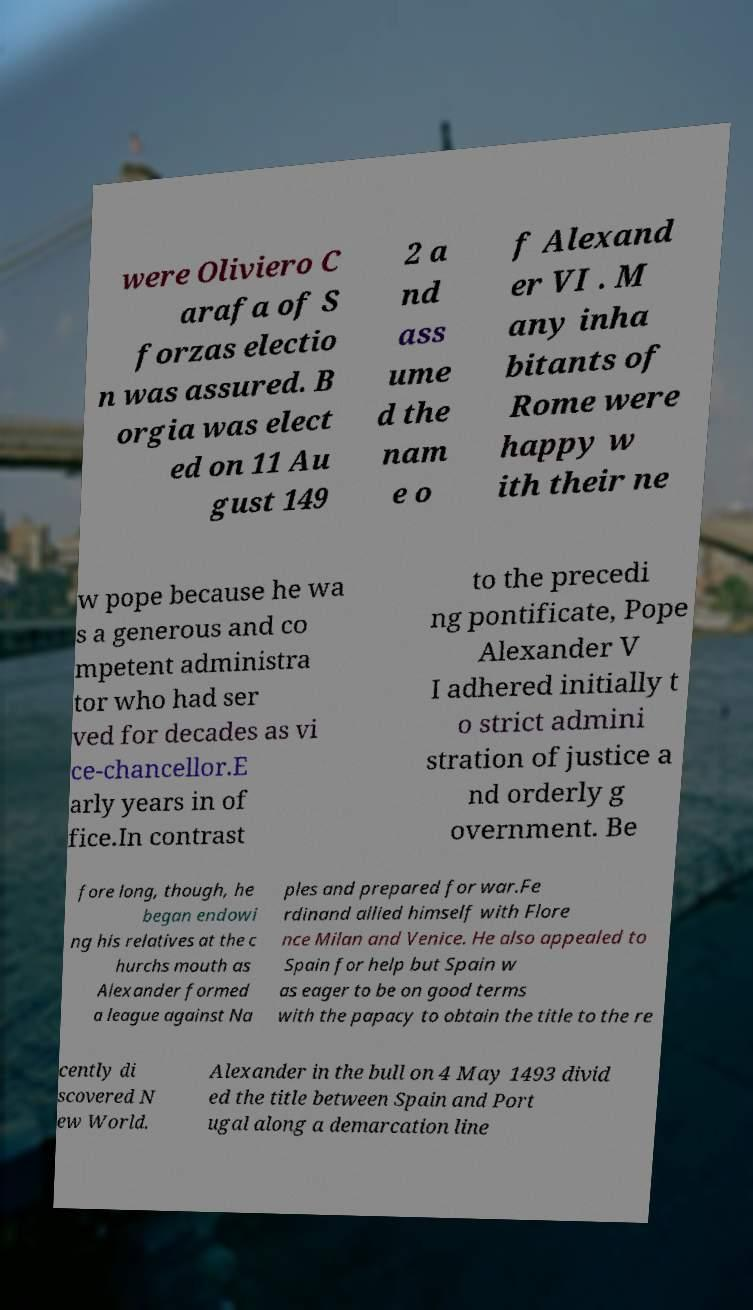Can you accurately transcribe the text from the provided image for me? were Oliviero C arafa of S forzas electio n was assured. B orgia was elect ed on 11 Au gust 149 2 a nd ass ume d the nam e o f Alexand er VI . M any inha bitants of Rome were happy w ith their ne w pope because he wa s a generous and co mpetent administra tor who had ser ved for decades as vi ce-chancellor.E arly years in of fice.In contrast to the precedi ng pontificate, Pope Alexander V I adhered initially t o strict admini stration of justice a nd orderly g overnment. Be fore long, though, he began endowi ng his relatives at the c hurchs mouth as Alexander formed a league against Na ples and prepared for war.Fe rdinand allied himself with Flore nce Milan and Venice. He also appealed to Spain for help but Spain w as eager to be on good terms with the papacy to obtain the title to the re cently di scovered N ew World. Alexander in the bull on 4 May 1493 divid ed the title between Spain and Port ugal along a demarcation line 